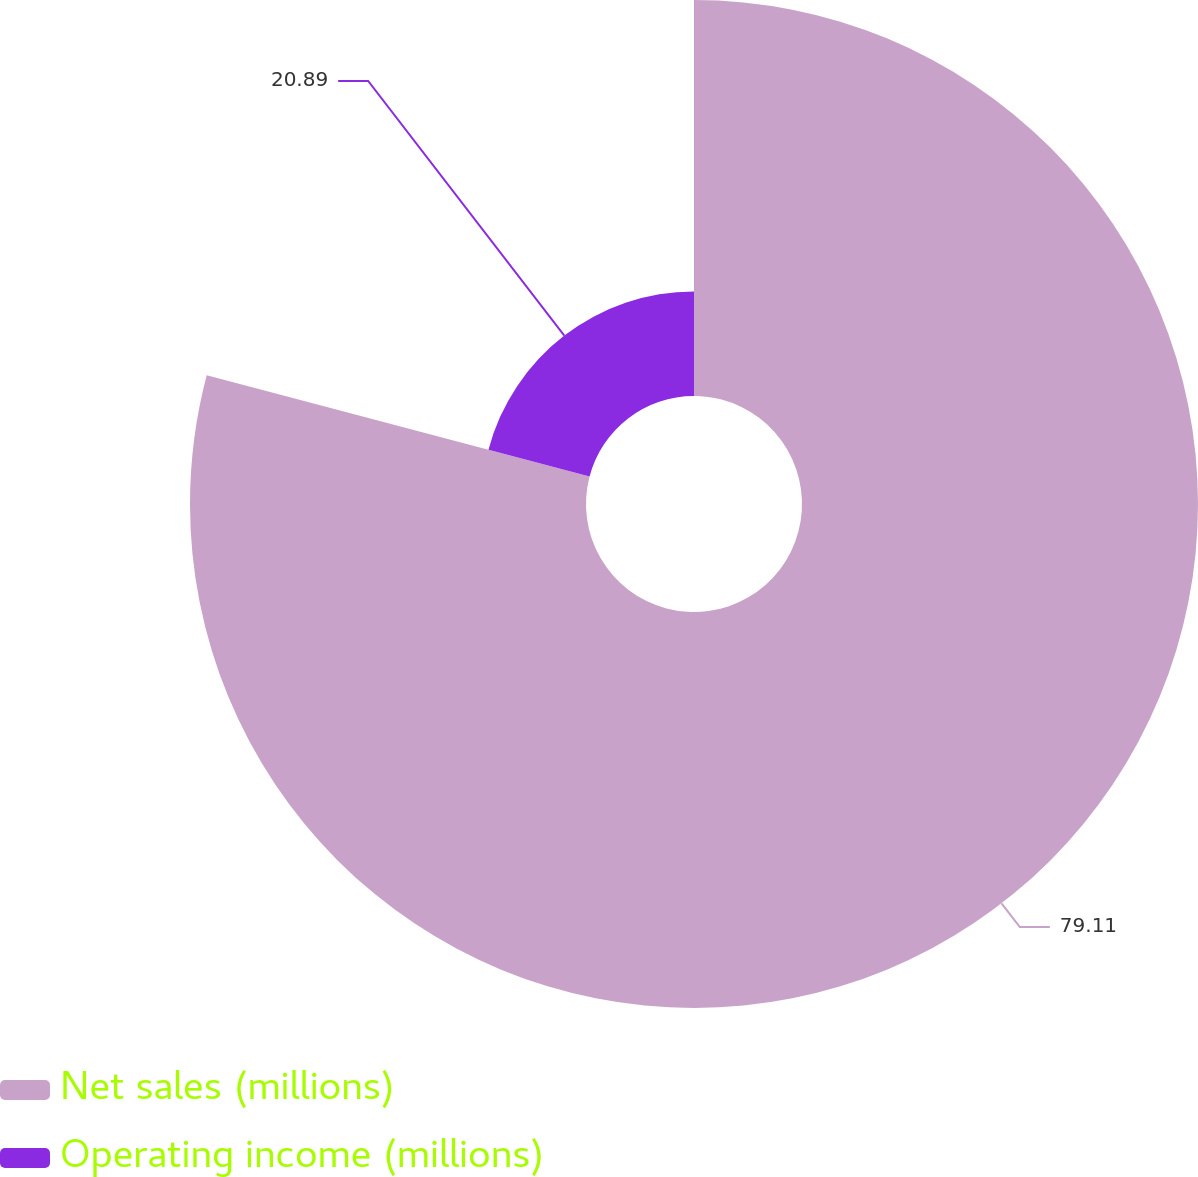Convert chart. <chart><loc_0><loc_0><loc_500><loc_500><pie_chart><fcel>Net sales (millions)<fcel>Operating income (millions)<nl><fcel>79.11%<fcel>20.89%<nl></chart> 